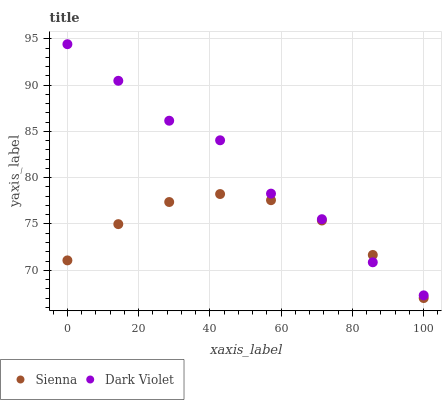Does Sienna have the minimum area under the curve?
Answer yes or no. Yes. Does Dark Violet have the maximum area under the curve?
Answer yes or no. Yes. Does Dark Violet have the minimum area under the curve?
Answer yes or no. No. Is Sienna the smoothest?
Answer yes or no. Yes. Is Dark Violet the roughest?
Answer yes or no. Yes. Is Dark Violet the smoothest?
Answer yes or no. No. Does Sienna have the lowest value?
Answer yes or no. Yes. Does Dark Violet have the lowest value?
Answer yes or no. No. Does Dark Violet have the highest value?
Answer yes or no. Yes. Does Sienna intersect Dark Violet?
Answer yes or no. Yes. Is Sienna less than Dark Violet?
Answer yes or no. No. Is Sienna greater than Dark Violet?
Answer yes or no. No. 